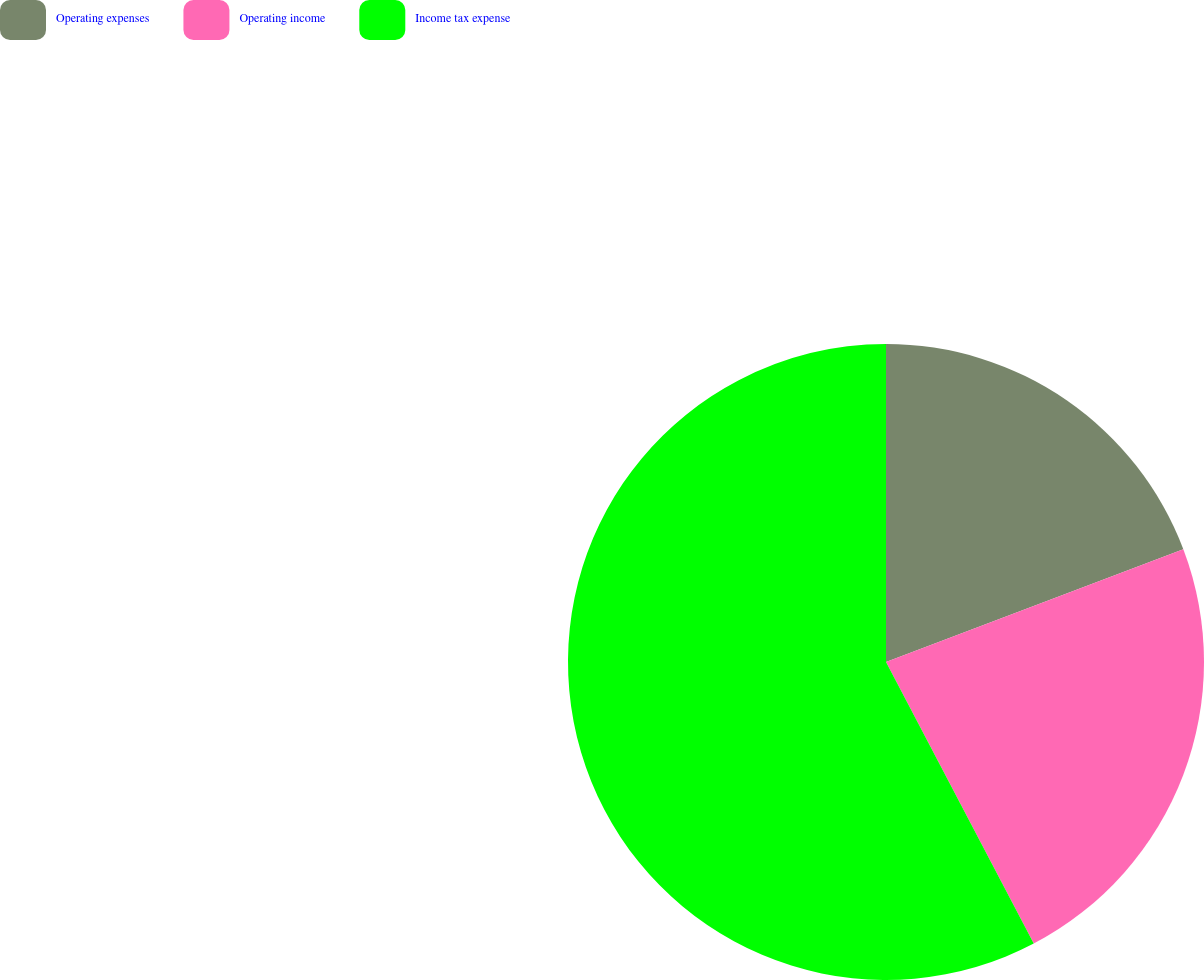Convert chart to OTSL. <chart><loc_0><loc_0><loc_500><loc_500><pie_chart><fcel>Operating expenses<fcel>Operating income<fcel>Income tax expense<nl><fcel>19.23%<fcel>23.08%<fcel>57.69%<nl></chart> 